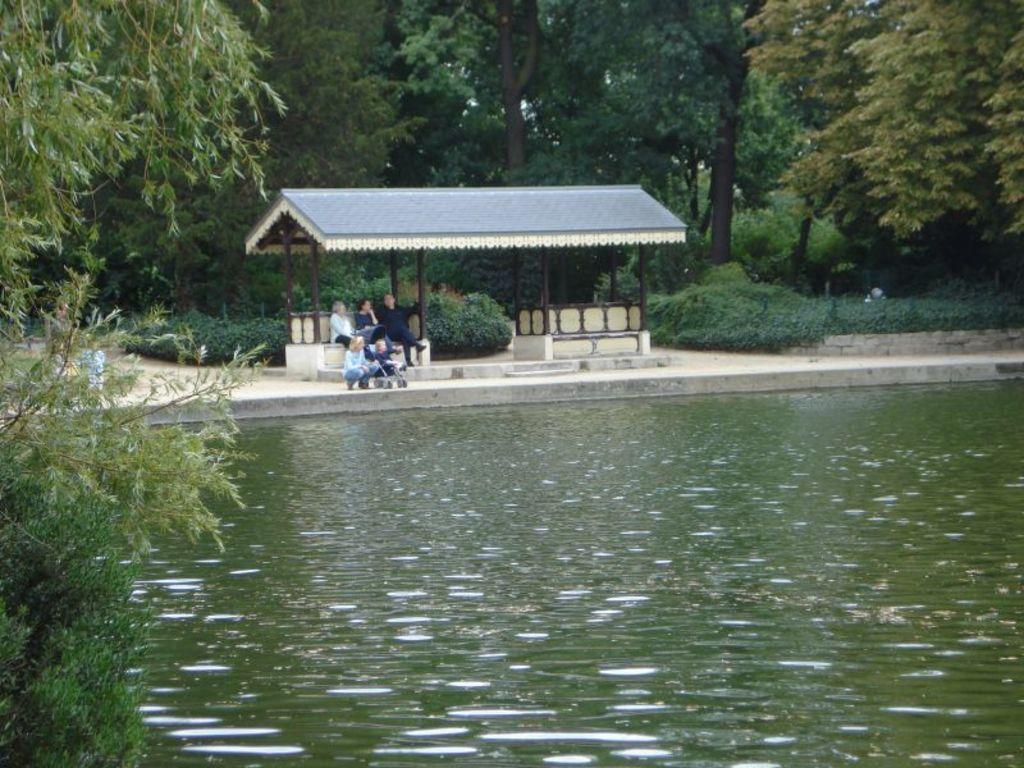How would you summarize this image in a sentence or two? On the left there are trees. In the foreground there is a water body. In the middle of the picture we can see planets, people, benches, a small roof. In the background there are trees. 